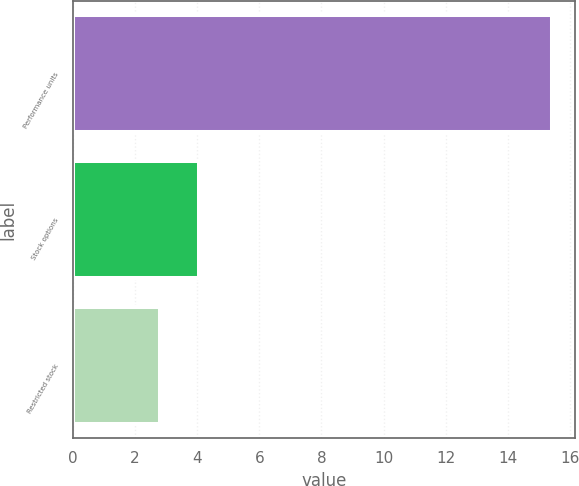<chart> <loc_0><loc_0><loc_500><loc_500><bar_chart><fcel>Performance units<fcel>Stock options<fcel>Restricted stock<nl><fcel>15.4<fcel>4.06<fcel>2.8<nl></chart> 